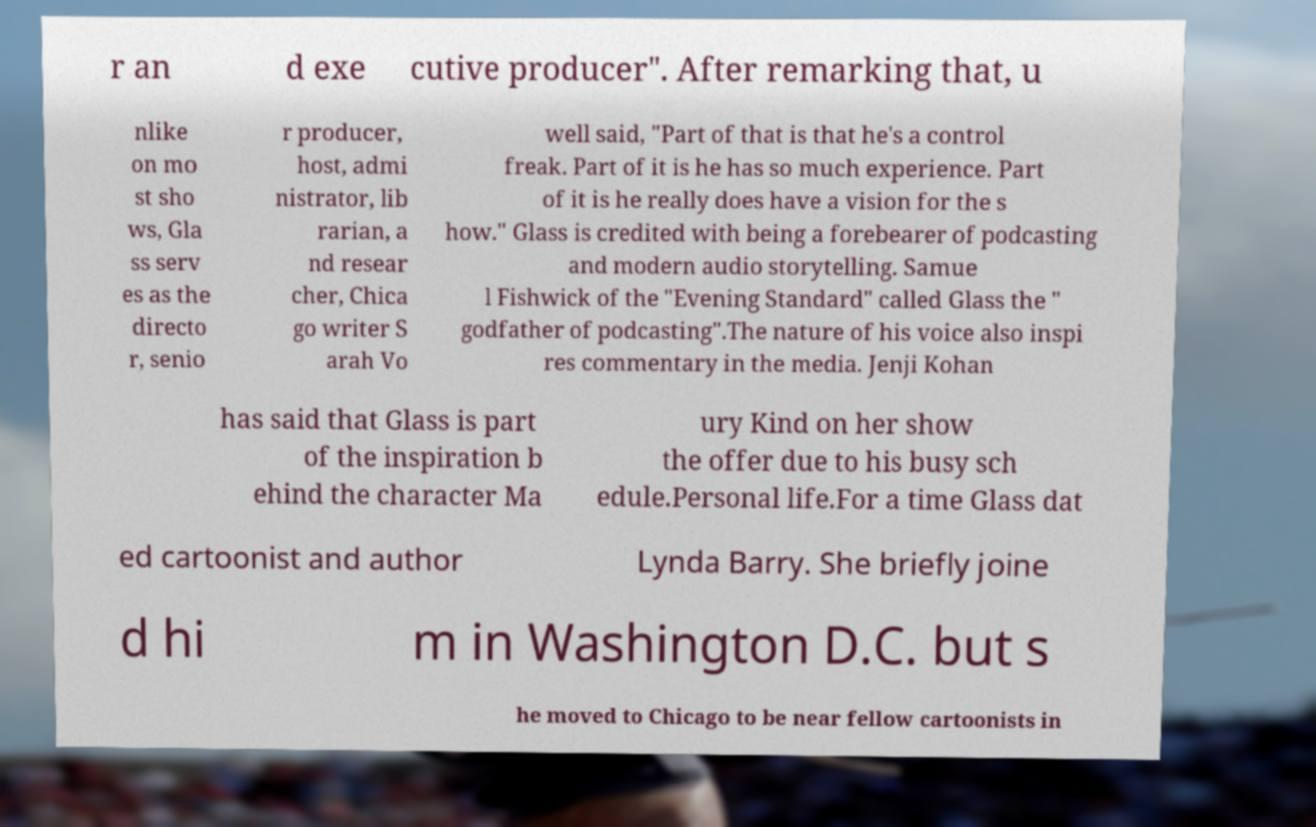Could you extract and type out the text from this image? r an d exe cutive producer". After remarking that, u nlike on mo st sho ws, Gla ss serv es as the directo r, senio r producer, host, admi nistrator, lib rarian, a nd resear cher, Chica go writer S arah Vo well said, "Part of that is that he's a control freak. Part of it is he has so much experience. Part of it is he really does have a vision for the s how." Glass is credited with being a forebearer of podcasting and modern audio storytelling. Samue l Fishwick of the "Evening Standard" called Glass the " godfather of podcasting".The nature of his voice also inspi res commentary in the media. Jenji Kohan has said that Glass is part of the inspiration b ehind the character Ma ury Kind on her show the offer due to his busy sch edule.Personal life.For a time Glass dat ed cartoonist and author Lynda Barry. She briefly joine d hi m in Washington D.C. but s he moved to Chicago to be near fellow cartoonists in 